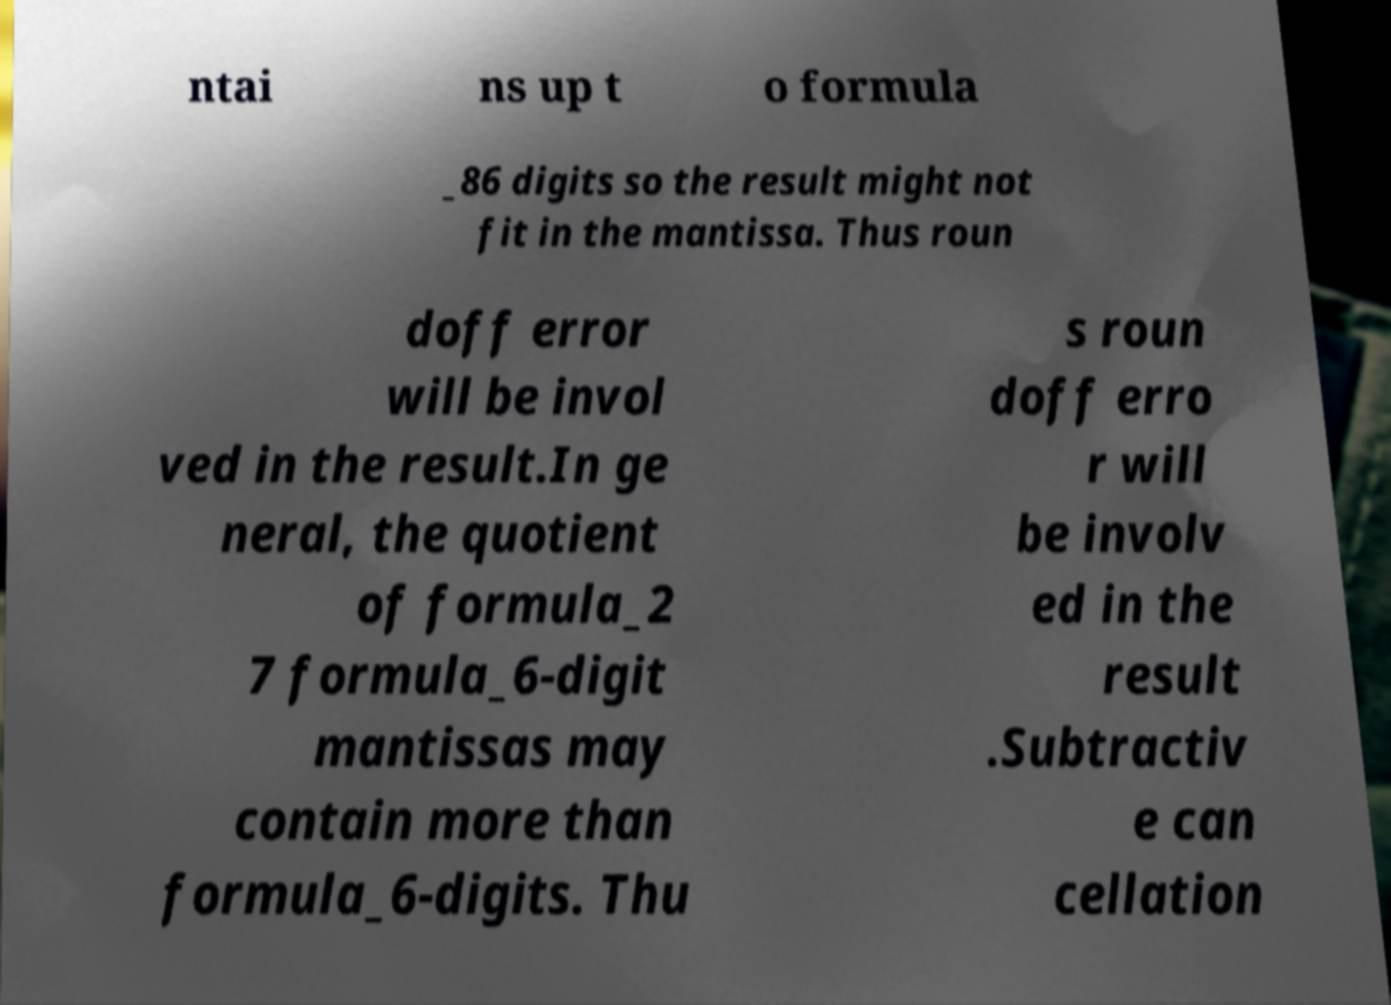I need the written content from this picture converted into text. Can you do that? ntai ns up t o formula _86 digits so the result might not fit in the mantissa. Thus roun doff error will be invol ved in the result.In ge neral, the quotient of formula_2 7 formula_6-digit mantissas may contain more than formula_6-digits. Thu s roun doff erro r will be involv ed in the result .Subtractiv e can cellation 